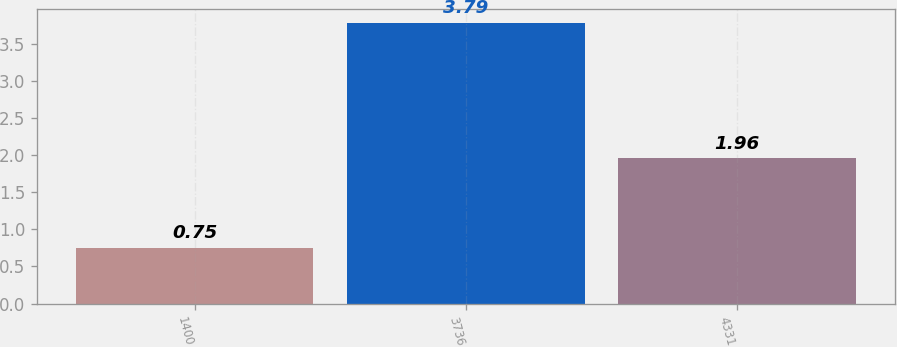<chart> <loc_0><loc_0><loc_500><loc_500><bar_chart><fcel>1400<fcel>3736<fcel>4331<nl><fcel>0.75<fcel>3.79<fcel>1.96<nl></chart> 